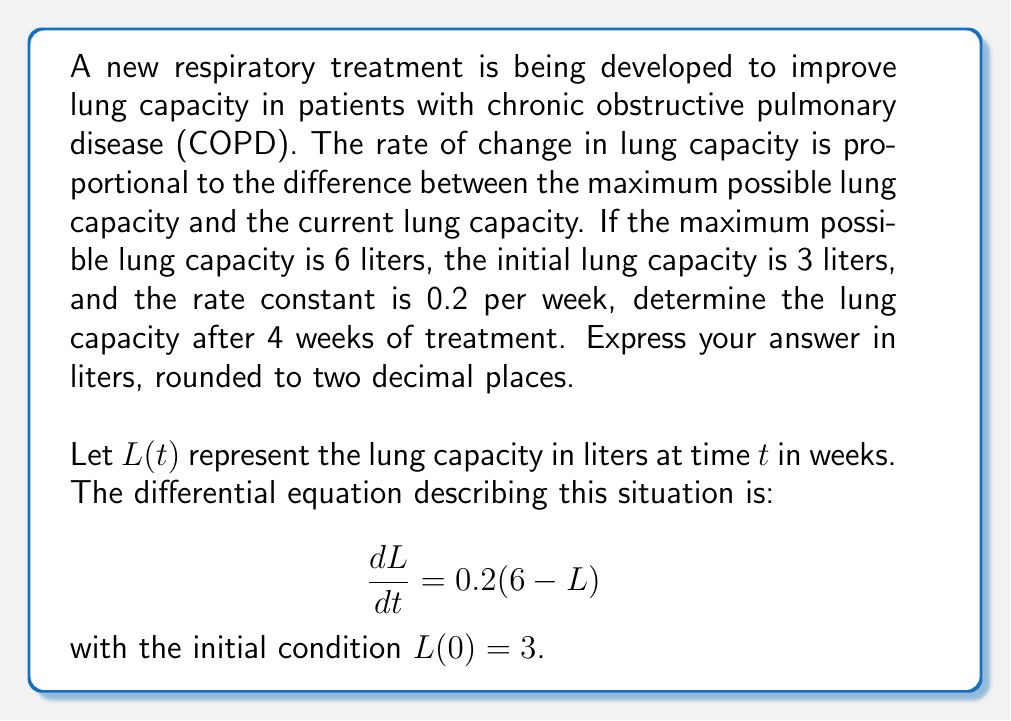What is the answer to this math problem? To solve this first-order linear differential equation, we follow these steps:

1) The general form of the equation is:
   $$\frac{dL}{dt} + 0.2L = 1.2$$

2) The integrating factor is:
   $$\mu(t) = e^{\int 0.2 dt} = e^{0.2t}$$

3) Multiply both sides of the equation by the integrating factor:
   $$e^{0.2t}\frac{dL}{dt} + 0.2Le^{0.2t} = 1.2e^{0.2t}$$

4) The left side is now the derivative of $Le^{0.2t}$:
   $$\frac{d}{dt}(Le^{0.2t}) = 1.2e^{0.2t}$$

5) Integrate both sides:
   $$Le^{0.2t} = 6 + C$$

6) Solve for $L$:
   $$L = 6 + Ce^{-0.2t}$$

7) Use the initial condition $L(0) = 3$ to find $C$:
   $$3 = 6 + C$$
   $$C = -3$$

8) The particular solution is:
   $$L(t) = 6 - 3e^{-0.2t}$$

9) To find the lung capacity after 4 weeks, evaluate $L(4)$:
   $$L(4) = 6 - 3e^{-0.2(4)} = 6 - 3e^{-0.8} \approx 4.86$$
Answer: The lung capacity after 4 weeks of treatment is approximately 4.86 liters. 